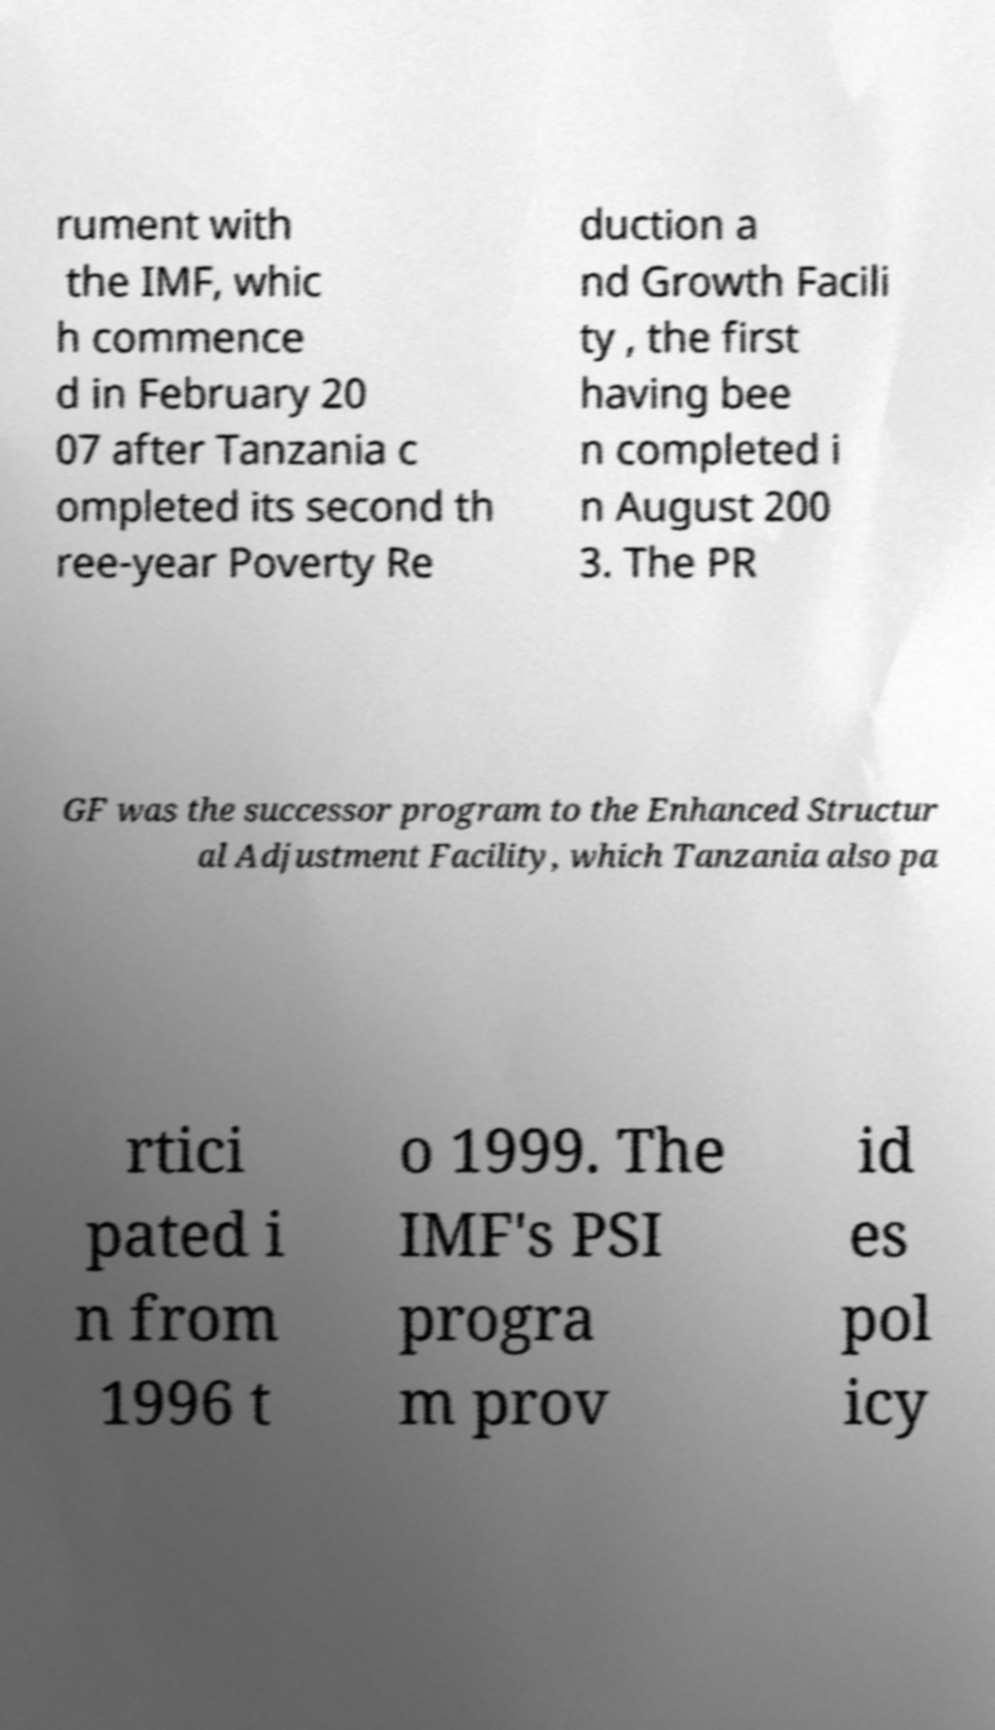Please identify and transcribe the text found in this image. rument with the IMF, whic h commence d in February 20 07 after Tanzania c ompleted its second th ree-year Poverty Re duction a nd Growth Facili ty , the first having bee n completed i n August 200 3. The PR GF was the successor program to the Enhanced Structur al Adjustment Facility, which Tanzania also pa rtici pated i n from 1996 t o 1999. The IMF's PSI progra m prov id es pol icy 